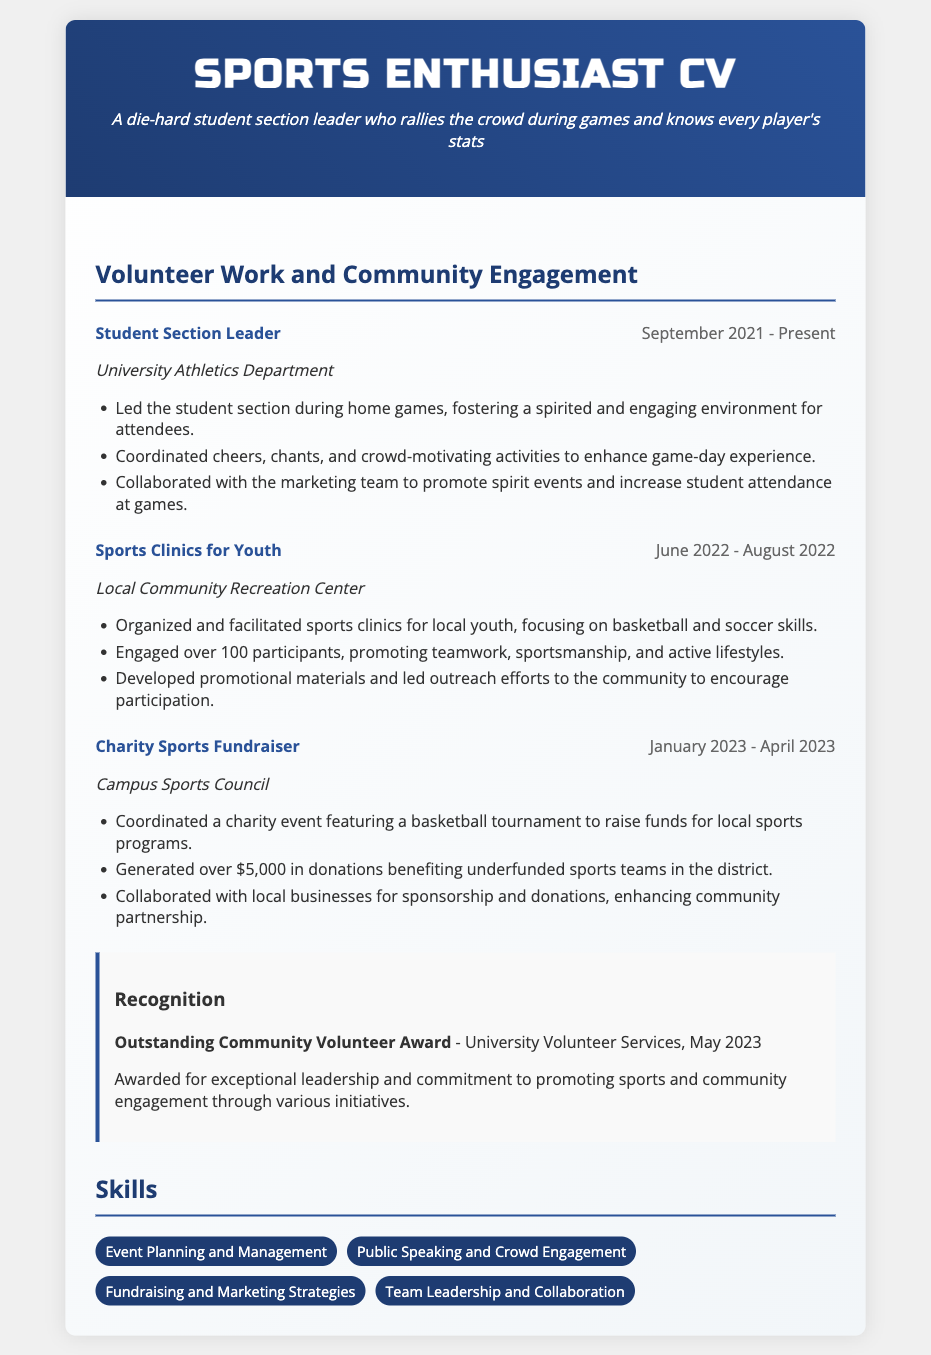what is the title of the CV? The title of the CV is presented at the top of the document, which indicates the purpose of the document.
Answer: Sports Enthusiast CV who is the organization for the Student Section Leader position? The organization for the Student Section Leader is mentioned directly below the title of that experience.
Answer: University Athletics Department how much money was generated from the Charity Sports Fundraiser? The amount generated from the Charity Sports Fundraiser is stated in the relevant experience section.
Answer: $5,000 during which months did the Sports Clinics for Youth take place? The months of the Sports Clinics for Youth are specified in the date range provided.
Answer: June 2022 - August 2022 what award was received in May 2023? The award is mentioned in the recognition section of the CV, reflecting the individual's achievements.
Answer: Outstanding Community Volunteer Award what is the main focus of the Sports Clinics for Youth? The main focus is derived from the description of the activities conducted during the clinics.
Answer: Basketball and soccer skills how many participants were engaged during the Sports Clinics for Youth? The number of participants is clearly stated in the description of that experience.
Answer: Over 100 which skills are highlighted in the Skills section? The skills listed in the Skills section provide insight into the individual's capabilities relevant to sports promotions and community engagement.
Answer: Event Planning and Management, Public Speaking and Crowd Engagement, Fundraising and Marketing Strategies, Team Leadership and Collaboration when did the Charity Sports Fundraiser start? The starting date of the Charity Sports Fundraiser is found in the date range of that experience.
Answer: January 2023 